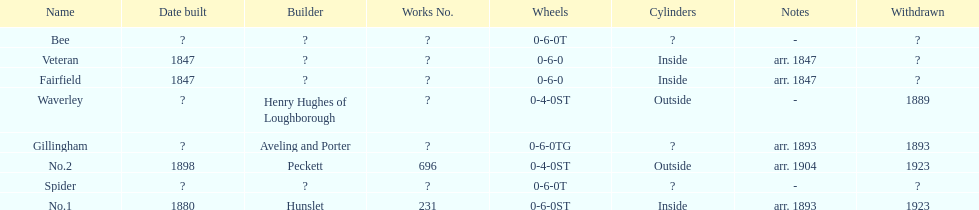Did fairfield or waverley have inside cylinders? Fairfield. 